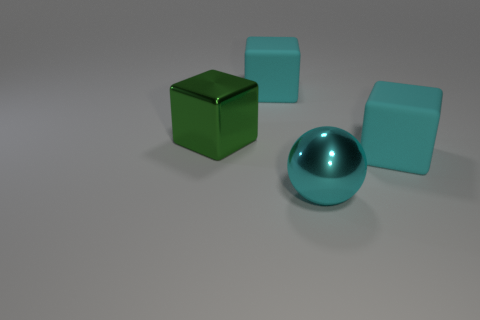Subtract all big rubber cubes. How many cubes are left? 1 Add 3 large cyan metallic blocks. How many objects exist? 7 Subtract all cyan cubes. How many cubes are left? 1 Subtract all blocks. How many objects are left? 1 Subtract all big brown metal things. Subtract all green cubes. How many objects are left? 3 Add 2 cyan metallic spheres. How many cyan metallic spheres are left? 3 Add 3 small metal blocks. How many small metal blocks exist? 3 Subtract 0 brown cubes. How many objects are left? 4 Subtract 2 blocks. How many blocks are left? 1 Subtract all green blocks. Subtract all blue spheres. How many blocks are left? 2 